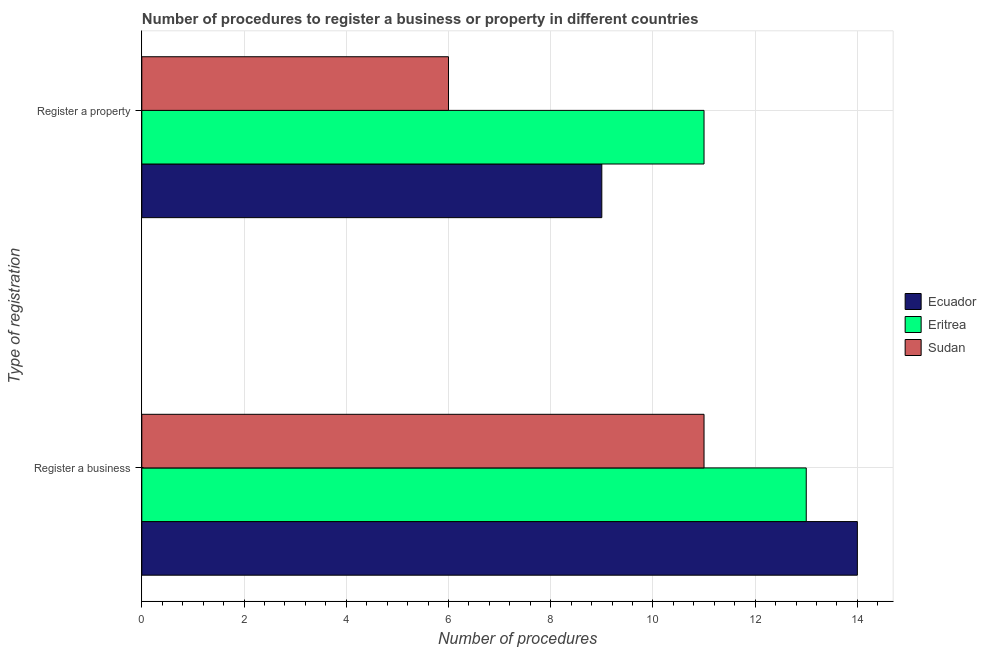How many different coloured bars are there?
Your response must be concise. 3. Are the number of bars per tick equal to the number of legend labels?
Ensure brevity in your answer.  Yes. How many bars are there on the 1st tick from the top?
Offer a terse response. 3. What is the label of the 2nd group of bars from the top?
Your answer should be very brief. Register a business. What is the number of procedures to register a property in Ecuador?
Ensure brevity in your answer.  9. Across all countries, what is the maximum number of procedures to register a business?
Ensure brevity in your answer.  14. Across all countries, what is the minimum number of procedures to register a property?
Your response must be concise. 6. In which country was the number of procedures to register a property maximum?
Keep it short and to the point. Eritrea. In which country was the number of procedures to register a property minimum?
Keep it short and to the point. Sudan. What is the total number of procedures to register a property in the graph?
Provide a succinct answer. 26. What is the difference between the number of procedures to register a business in Eritrea and that in Sudan?
Offer a terse response. 2. What is the difference between the number of procedures to register a business in Ecuador and the number of procedures to register a property in Sudan?
Offer a terse response. 8. What is the average number of procedures to register a business per country?
Keep it short and to the point. 12.67. What is the difference between the number of procedures to register a property and number of procedures to register a business in Eritrea?
Offer a very short reply. -2. What is the ratio of the number of procedures to register a business in Eritrea to that in Ecuador?
Your response must be concise. 0.93. Is the number of procedures to register a property in Ecuador less than that in Sudan?
Offer a terse response. No. In how many countries, is the number of procedures to register a property greater than the average number of procedures to register a property taken over all countries?
Keep it short and to the point. 2. What does the 1st bar from the top in Register a business represents?
Provide a succinct answer. Sudan. What does the 2nd bar from the bottom in Register a property represents?
Keep it short and to the point. Eritrea. How many countries are there in the graph?
Provide a succinct answer. 3. Are the values on the major ticks of X-axis written in scientific E-notation?
Offer a very short reply. No. Does the graph contain any zero values?
Your answer should be very brief. No. How are the legend labels stacked?
Your answer should be very brief. Vertical. What is the title of the graph?
Your response must be concise. Number of procedures to register a business or property in different countries. Does "Curacao" appear as one of the legend labels in the graph?
Offer a very short reply. No. What is the label or title of the X-axis?
Your answer should be compact. Number of procedures. What is the label or title of the Y-axis?
Your response must be concise. Type of registration. What is the Number of procedures of Ecuador in Register a business?
Your answer should be very brief. 14. What is the Number of procedures in Eritrea in Register a business?
Your answer should be very brief. 13. What is the Number of procedures of Ecuador in Register a property?
Provide a short and direct response. 9. What is the Number of procedures of Sudan in Register a property?
Your response must be concise. 6. Across all Type of registration, what is the maximum Number of procedures in Ecuador?
Make the answer very short. 14. Across all Type of registration, what is the maximum Number of procedures of Eritrea?
Provide a succinct answer. 13. Across all Type of registration, what is the maximum Number of procedures in Sudan?
Offer a very short reply. 11. What is the total Number of procedures in Eritrea in the graph?
Offer a very short reply. 24. What is the total Number of procedures in Sudan in the graph?
Make the answer very short. 17. What is the average Number of procedures in Ecuador per Type of registration?
Provide a succinct answer. 11.5. What is the average Number of procedures in Eritrea per Type of registration?
Your response must be concise. 12. What is the difference between the Number of procedures in Ecuador and Number of procedures in Eritrea in Register a business?
Keep it short and to the point. 1. What is the difference between the Number of procedures in Ecuador and Number of procedures in Sudan in Register a business?
Your response must be concise. 3. What is the difference between the Number of procedures in Eritrea and Number of procedures in Sudan in Register a property?
Provide a succinct answer. 5. What is the ratio of the Number of procedures in Ecuador in Register a business to that in Register a property?
Offer a very short reply. 1.56. What is the ratio of the Number of procedures of Eritrea in Register a business to that in Register a property?
Give a very brief answer. 1.18. What is the ratio of the Number of procedures of Sudan in Register a business to that in Register a property?
Ensure brevity in your answer.  1.83. What is the difference between the highest and the second highest Number of procedures of Sudan?
Provide a succinct answer. 5. What is the difference between the highest and the lowest Number of procedures of Ecuador?
Provide a short and direct response. 5. What is the difference between the highest and the lowest Number of procedures in Eritrea?
Your answer should be compact. 2. 